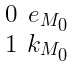Convert formula to latex. <formula><loc_0><loc_0><loc_500><loc_500>\begin{smallmatrix} 0 & e _ { M _ { 0 } } \\ 1 & k _ { M _ { 0 } } \end{smallmatrix}</formula> 